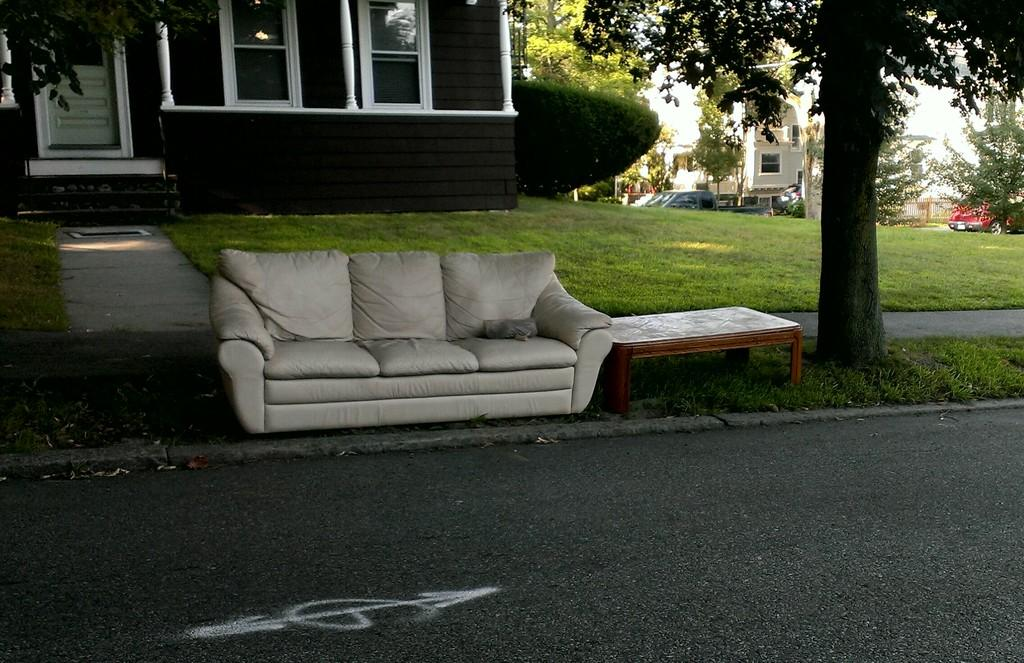What type of furniture is present in the image? There is a sofa and a table in the image. Where are the sofa and table located? The sofa and table are placed beside a road. What other structure can be seen in the image? There is a house in the image. How many snakes are slithering on the sofa in the image? There are no snakes present in the image; only the sofa, table, and house can be seen. What type of alarm is going off in the image? There is no alarm going off in the image; it is a quiet scene with a sofa, table, and house. 